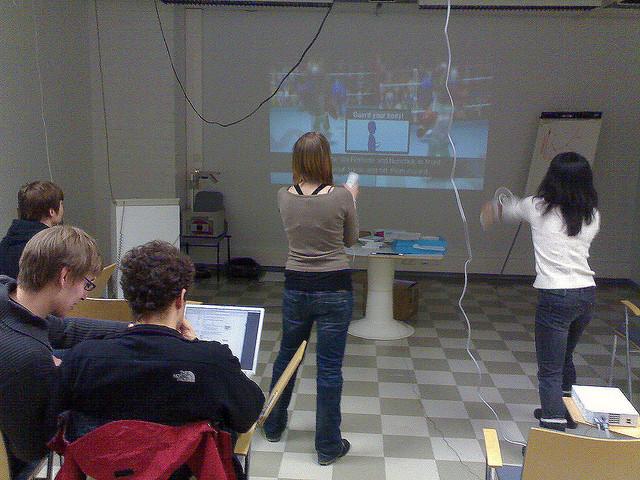What game console are they playing?
Keep it brief. Wii. What is the woman standing on?
Concise answer only. Floor. What are the guy's looking at on the computer?
Give a very brief answer. Web page. Onto what is the video game being projected?
Write a very short answer. Wall. Where are the frames?
Answer briefly. On wall. 